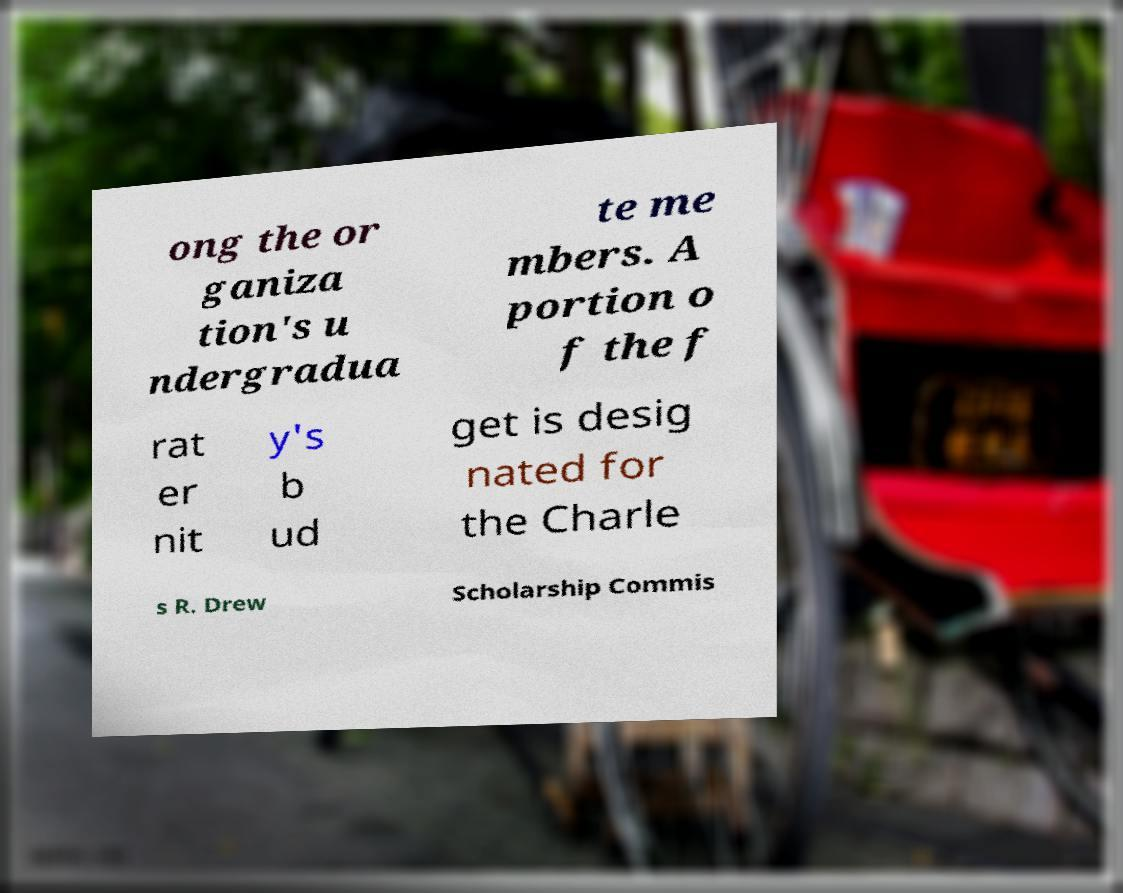Could you extract and type out the text from this image? ong the or ganiza tion's u ndergradua te me mbers. A portion o f the f rat er nit y's b ud get is desig nated for the Charle s R. Drew Scholarship Commis 